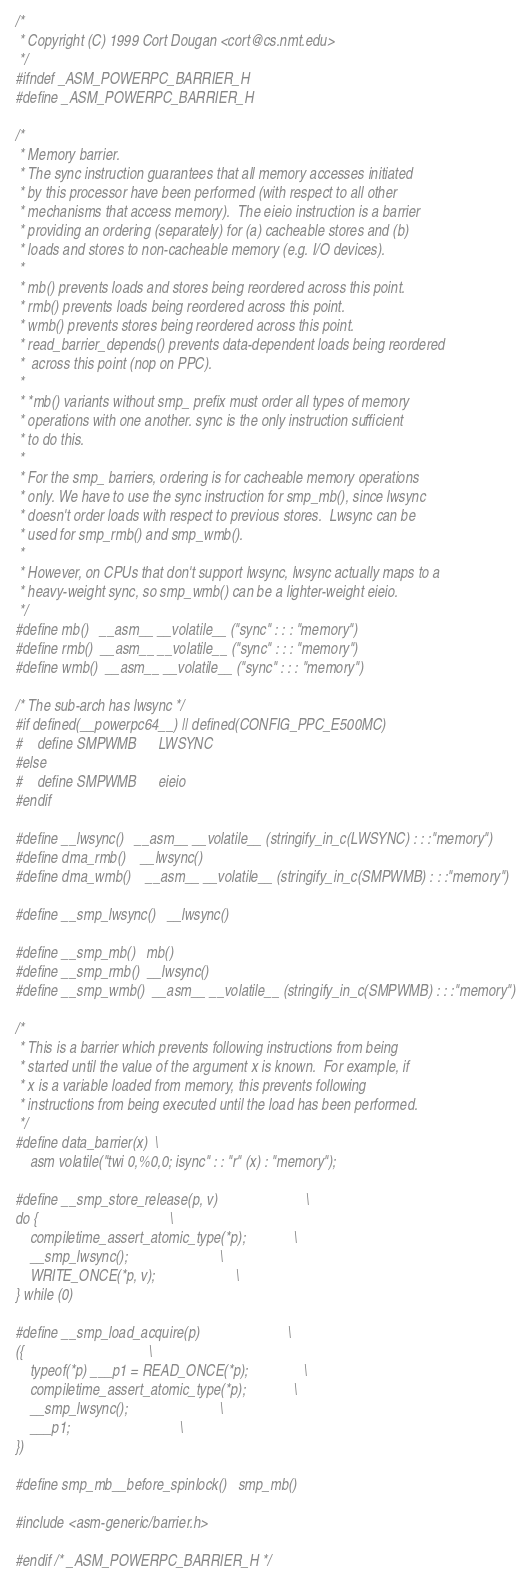<code> <loc_0><loc_0><loc_500><loc_500><_C_>/*
 * Copyright (C) 1999 Cort Dougan <cort@cs.nmt.edu>
 */
#ifndef _ASM_POWERPC_BARRIER_H
#define _ASM_POWERPC_BARRIER_H

/*
 * Memory barrier.
 * The sync instruction guarantees that all memory accesses initiated
 * by this processor have been performed (with respect to all other
 * mechanisms that access memory).  The eieio instruction is a barrier
 * providing an ordering (separately) for (a) cacheable stores and (b)
 * loads and stores to non-cacheable memory (e.g. I/O devices).
 *
 * mb() prevents loads and stores being reordered across this point.
 * rmb() prevents loads being reordered across this point.
 * wmb() prevents stores being reordered across this point.
 * read_barrier_depends() prevents data-dependent loads being reordered
 *	across this point (nop on PPC).
 *
 * *mb() variants without smp_ prefix must order all types of memory
 * operations with one another. sync is the only instruction sufficient
 * to do this.
 *
 * For the smp_ barriers, ordering is for cacheable memory operations
 * only. We have to use the sync instruction for smp_mb(), since lwsync
 * doesn't order loads with respect to previous stores.  Lwsync can be
 * used for smp_rmb() and smp_wmb().
 *
 * However, on CPUs that don't support lwsync, lwsync actually maps to a
 * heavy-weight sync, so smp_wmb() can be a lighter-weight eieio.
 */
#define mb()   __asm__ __volatile__ ("sync" : : : "memory")
#define rmb()  __asm__ __volatile__ ("sync" : : : "memory")
#define wmb()  __asm__ __volatile__ ("sync" : : : "memory")

/* The sub-arch has lwsync */
#if defined(__powerpc64__) || defined(CONFIG_PPC_E500MC)
#    define SMPWMB      LWSYNC
#else
#    define SMPWMB      eieio
#endif

#define __lwsync()	__asm__ __volatile__ (stringify_in_c(LWSYNC) : : :"memory")
#define dma_rmb()	__lwsync()
#define dma_wmb()	__asm__ __volatile__ (stringify_in_c(SMPWMB) : : :"memory")

#define __smp_lwsync()	__lwsync()

#define __smp_mb()	mb()
#define __smp_rmb()	__lwsync()
#define __smp_wmb()	__asm__ __volatile__ (stringify_in_c(SMPWMB) : : :"memory")

/*
 * This is a barrier which prevents following instructions from being
 * started until the value of the argument x is known.  For example, if
 * x is a variable loaded from memory, this prevents following
 * instructions from being executed until the load has been performed.
 */
#define data_barrier(x)	\
	asm volatile("twi 0,%0,0; isync" : : "r" (x) : "memory");

#define __smp_store_release(p, v)						\
do {									\
	compiletime_assert_atomic_type(*p);				\
	__smp_lwsync();							\
	WRITE_ONCE(*p, v);						\
} while (0)

#define __smp_load_acquire(p)						\
({									\
	typeof(*p) ___p1 = READ_ONCE(*p);				\
	compiletime_assert_atomic_type(*p);				\
	__smp_lwsync();							\
	___p1;								\
})

#define smp_mb__before_spinlock()   smp_mb()

#include <asm-generic/barrier.h>

#endif /* _ASM_POWERPC_BARRIER_H */
</code> 